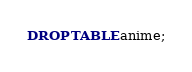Convert code to text. <code><loc_0><loc_0><loc_500><loc_500><_SQL_>DROP TABLE anime;
</code> 